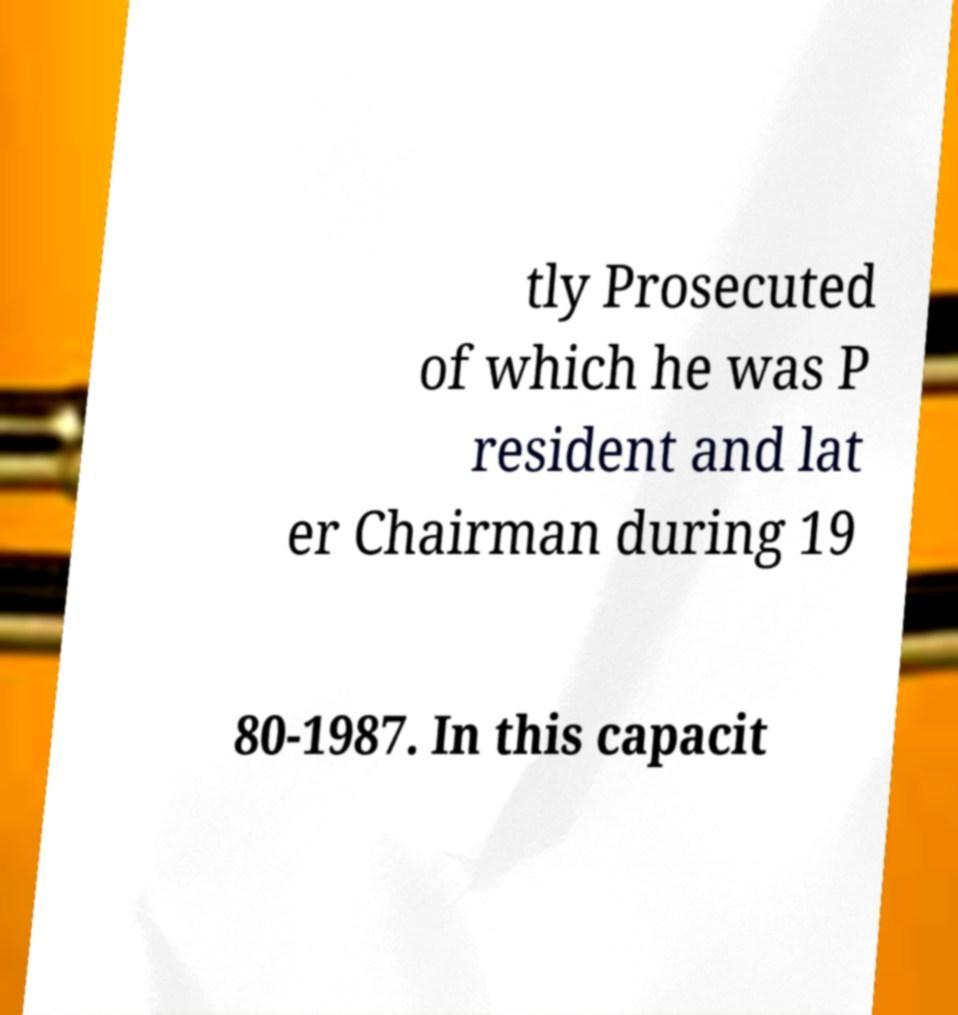Please identify and transcribe the text found in this image. tly Prosecuted of which he was P resident and lat er Chairman during 19 80-1987. In this capacit 